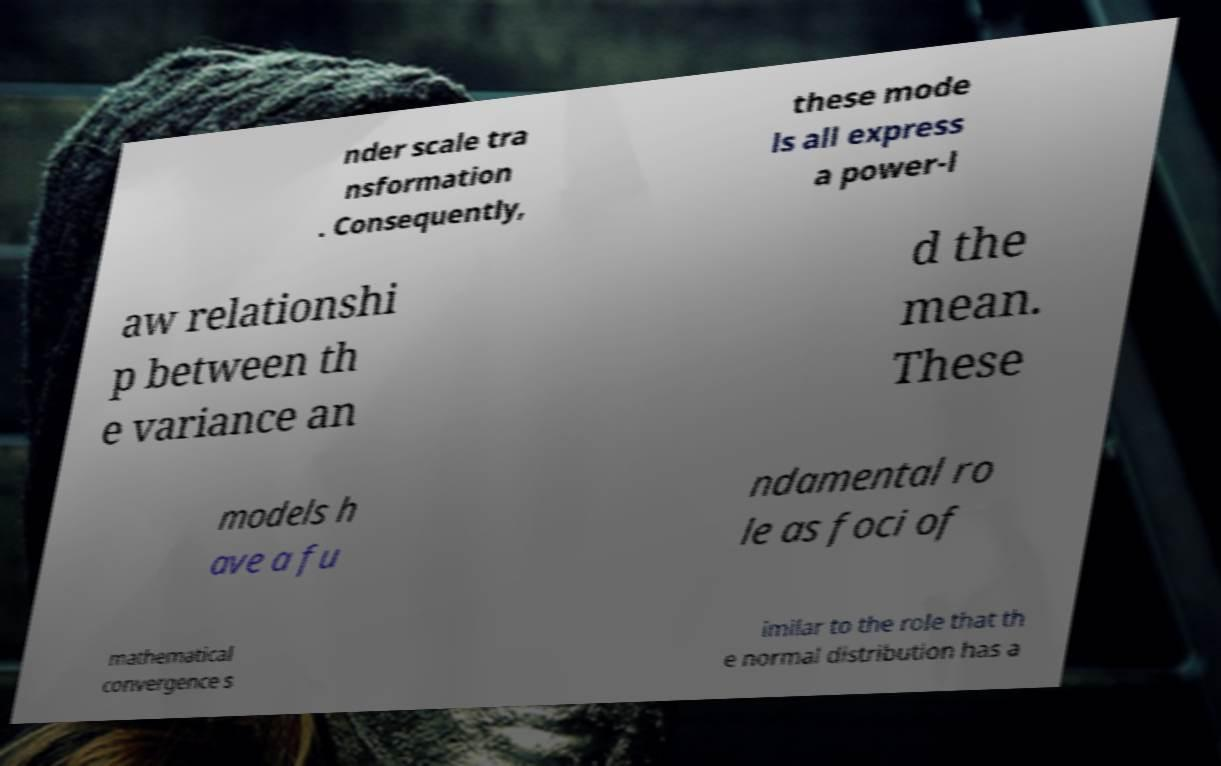Can you accurately transcribe the text from the provided image for me? nder scale tra nsformation . Consequently, these mode ls all express a power-l aw relationshi p between th e variance an d the mean. These models h ave a fu ndamental ro le as foci of mathematical convergence s imilar to the role that th e normal distribution has a 